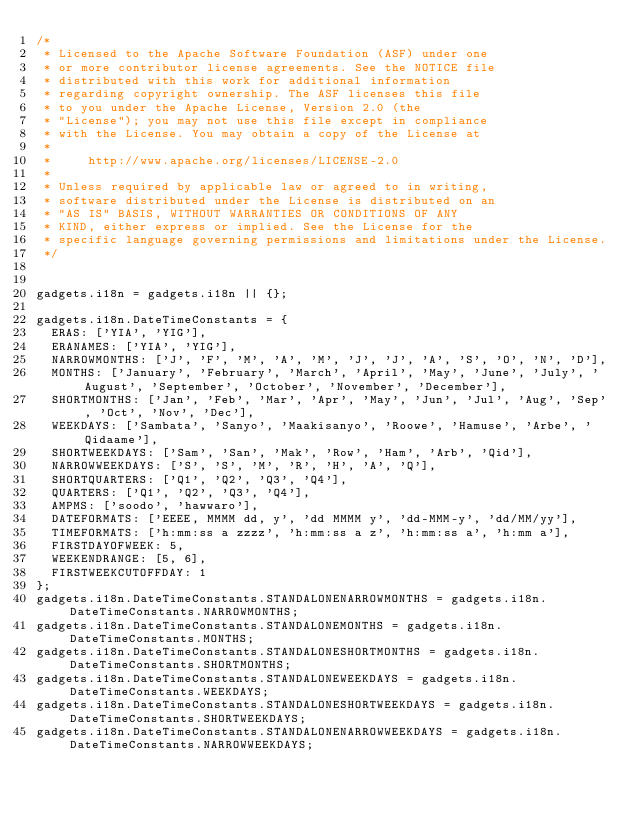Convert code to text. <code><loc_0><loc_0><loc_500><loc_500><_JavaScript_>/*
 * Licensed to the Apache Software Foundation (ASF) under one
 * or more contributor license agreements. See the NOTICE file
 * distributed with this work for additional information
 * regarding copyright ownership. The ASF licenses this file
 * to you under the Apache License, Version 2.0 (the
 * "License"); you may not use this file except in compliance
 * with the License. You may obtain a copy of the License at
 *
 *     http://www.apache.org/licenses/LICENSE-2.0
 *
 * Unless required by applicable law or agreed to in writing,
 * software distributed under the License is distributed on an
 * "AS IS" BASIS, WITHOUT WARRANTIES OR CONDITIONS OF ANY
 * KIND, either express or implied. See the License for the
 * specific language governing permissions and limitations under the License.
 */


gadgets.i18n = gadgets.i18n || {};

gadgets.i18n.DateTimeConstants = {
  ERAS: ['YIA', 'YIG'],
  ERANAMES: ['YIA', 'YIG'],
  NARROWMONTHS: ['J', 'F', 'M', 'A', 'M', 'J', 'J', 'A', 'S', 'O', 'N', 'D'],
  MONTHS: ['January', 'February', 'March', 'April', 'May', 'June', 'July', 'August', 'September', 'October', 'November', 'December'],
  SHORTMONTHS: ['Jan', 'Feb', 'Mar', 'Apr', 'May', 'Jun', 'Jul', 'Aug', 'Sep', 'Oct', 'Nov', 'Dec'],
  WEEKDAYS: ['Sambata', 'Sanyo', 'Maakisanyo', 'Roowe', 'Hamuse', 'Arbe', 'Qidaame'],
  SHORTWEEKDAYS: ['Sam', 'San', 'Mak', 'Row', 'Ham', 'Arb', 'Qid'],
  NARROWWEEKDAYS: ['S', 'S', 'M', 'R', 'H', 'A', 'Q'],
  SHORTQUARTERS: ['Q1', 'Q2', 'Q3', 'Q4'],
  QUARTERS: ['Q1', 'Q2', 'Q3', 'Q4'],
  AMPMS: ['soodo', 'hawwaro'],
  DATEFORMATS: ['EEEE, MMMM dd, y', 'dd MMMM y', 'dd-MMM-y', 'dd/MM/yy'],
  TIMEFORMATS: ['h:mm:ss a zzzz', 'h:mm:ss a z', 'h:mm:ss a', 'h:mm a'],
  FIRSTDAYOFWEEK: 5,
  WEEKENDRANGE: [5, 6],
  FIRSTWEEKCUTOFFDAY: 1
};
gadgets.i18n.DateTimeConstants.STANDALONENARROWMONTHS = gadgets.i18n.DateTimeConstants.NARROWMONTHS;
gadgets.i18n.DateTimeConstants.STANDALONEMONTHS = gadgets.i18n.DateTimeConstants.MONTHS;
gadgets.i18n.DateTimeConstants.STANDALONESHORTMONTHS = gadgets.i18n.DateTimeConstants.SHORTMONTHS;
gadgets.i18n.DateTimeConstants.STANDALONEWEEKDAYS = gadgets.i18n.DateTimeConstants.WEEKDAYS;
gadgets.i18n.DateTimeConstants.STANDALONESHORTWEEKDAYS = gadgets.i18n.DateTimeConstants.SHORTWEEKDAYS;
gadgets.i18n.DateTimeConstants.STANDALONENARROWWEEKDAYS = gadgets.i18n.DateTimeConstants.NARROWWEEKDAYS;
</code> 